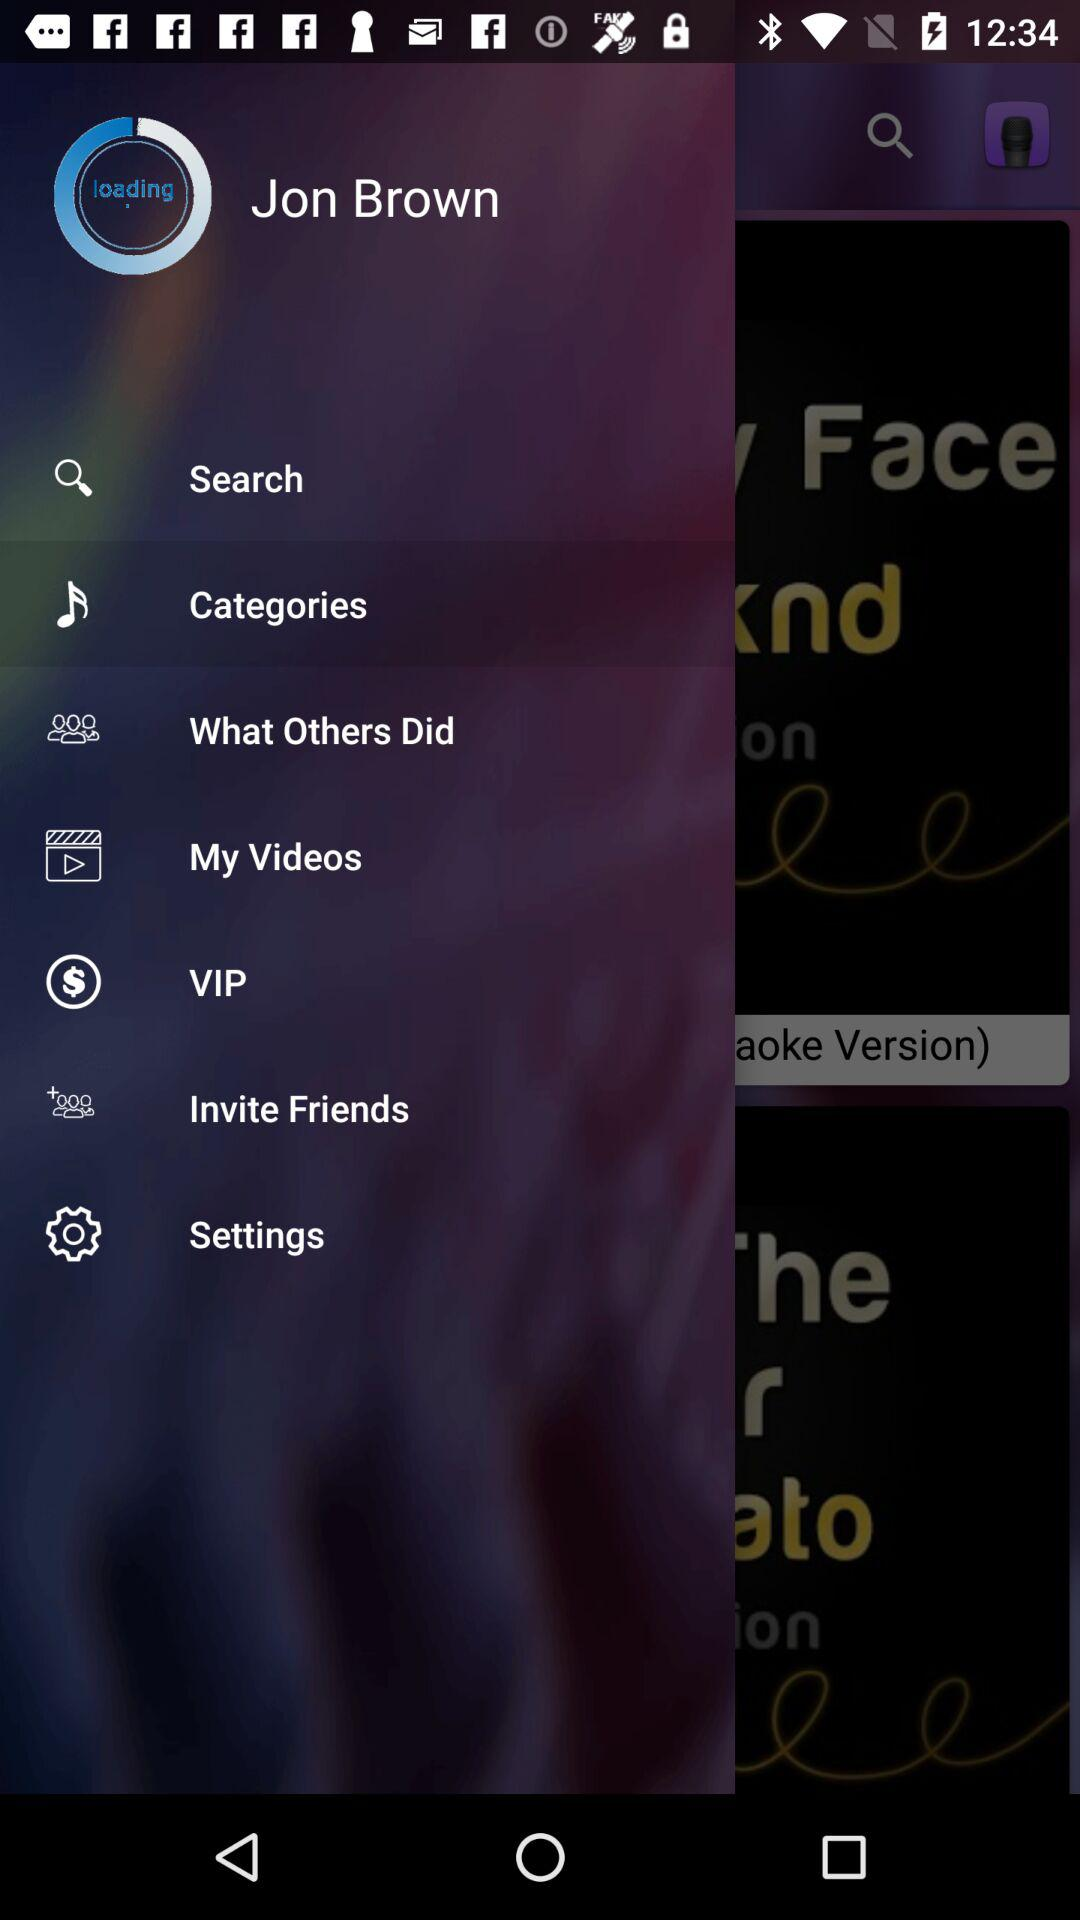What is the name of the user? The name of the user is Jon Brown. 